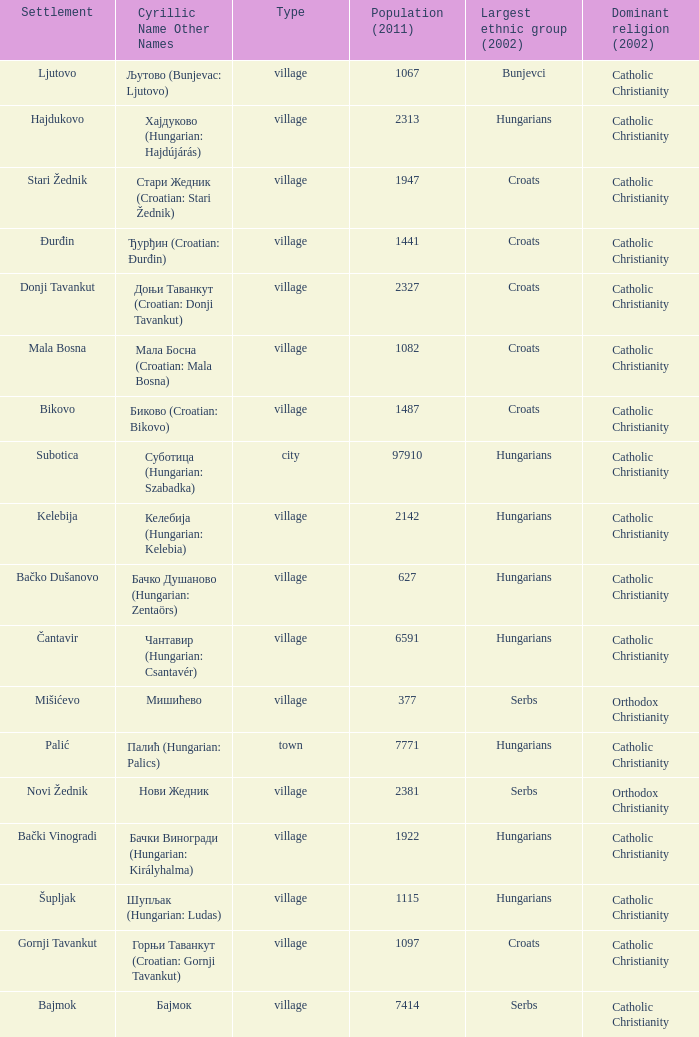Could you parse the entire table as a dict? {'header': ['Settlement', 'Cyrillic Name Other Names', 'Type', 'Population (2011)', 'Largest ethnic group (2002)', 'Dominant religion (2002)'], 'rows': [['Ljutovo', 'Љутово (Bunjevac: Ljutovo)', 'village', '1067', 'Bunjevci', 'Catholic Christianity'], ['Hajdukovo', 'Хајдуково (Hungarian: Hajdújárás)', 'village', '2313', 'Hungarians', 'Catholic Christianity'], ['Stari Žednik', 'Стари Жедник (Croatian: Stari Žednik)', 'village', '1947', 'Croats', 'Catholic Christianity'], ['Đurđin', 'Ђурђин (Croatian: Đurđin)', 'village', '1441', 'Croats', 'Catholic Christianity'], ['Donji Tavankut', 'Доњи Таванкут (Croatian: Donji Tavankut)', 'village', '2327', 'Croats', 'Catholic Christianity'], ['Mala Bosna', 'Мала Босна (Croatian: Mala Bosna)', 'village', '1082', 'Croats', 'Catholic Christianity'], ['Bikovo', 'Биково (Croatian: Bikovo)', 'village', '1487', 'Croats', 'Catholic Christianity'], ['Subotica', 'Суботица (Hungarian: Szabadka)', 'city', '97910', 'Hungarians', 'Catholic Christianity'], ['Kelebija', 'Келебија (Hungarian: Kelebia)', 'village', '2142', 'Hungarians', 'Catholic Christianity'], ['Bačko Dušanovo', 'Бачко Душаново (Hungarian: Zentaörs)', 'village', '627', 'Hungarians', 'Catholic Christianity'], ['Čantavir', 'Чантавир (Hungarian: Csantavér)', 'village', '6591', 'Hungarians', 'Catholic Christianity'], ['Mišićevo', 'Мишићево', 'village', '377', 'Serbs', 'Orthodox Christianity'], ['Palić', 'Палић (Hungarian: Palics)', 'town', '7771', 'Hungarians', 'Catholic Christianity'], ['Novi Žednik', 'Нови Жедник', 'village', '2381', 'Serbs', 'Orthodox Christianity'], ['Bački Vinogradi', 'Бачки Виногради (Hungarian: Királyhalma)', 'village', '1922', 'Hungarians', 'Catholic Christianity'], ['Šupljak', 'Шупљак (Hungarian: Ludas)', 'village', '1115', 'Hungarians', 'Catholic Christianity'], ['Gornji Tavankut', 'Горњи Таванкут (Croatian: Gornji Tavankut)', 'village', '1097', 'Croats', 'Catholic Christianity'], ['Bajmok', 'Бајмок', 'village', '7414', 'Serbs', 'Catholic Christianity']]} How many settlements are named ђурђин (croatian: đurđin)? 1.0. 